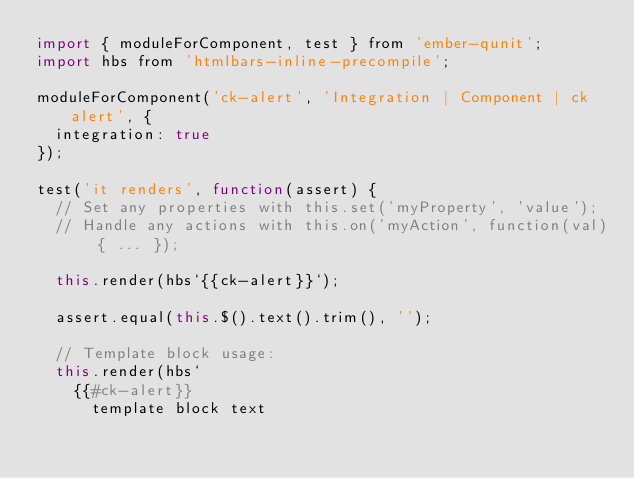<code> <loc_0><loc_0><loc_500><loc_500><_JavaScript_>import { moduleForComponent, test } from 'ember-qunit';
import hbs from 'htmlbars-inline-precompile';

moduleForComponent('ck-alert', 'Integration | Component | ck alert', {
  integration: true
});

test('it renders', function(assert) {
  // Set any properties with this.set('myProperty', 'value');
  // Handle any actions with this.on('myAction', function(val) { ... });

  this.render(hbs`{{ck-alert}}`);

  assert.equal(this.$().text().trim(), '');

  // Template block usage:
  this.render(hbs`
    {{#ck-alert}}
      template block text</code> 